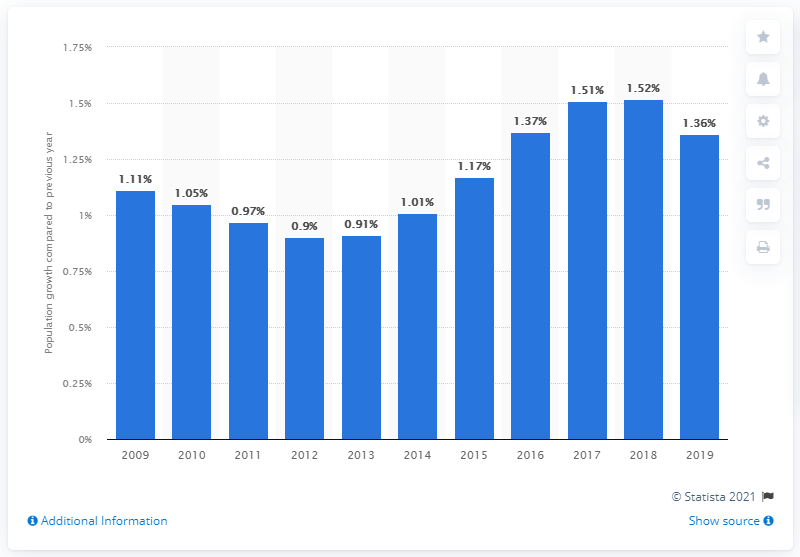Give some essential details in this illustration. Colombia's population increased by 1.36% in 2019. 